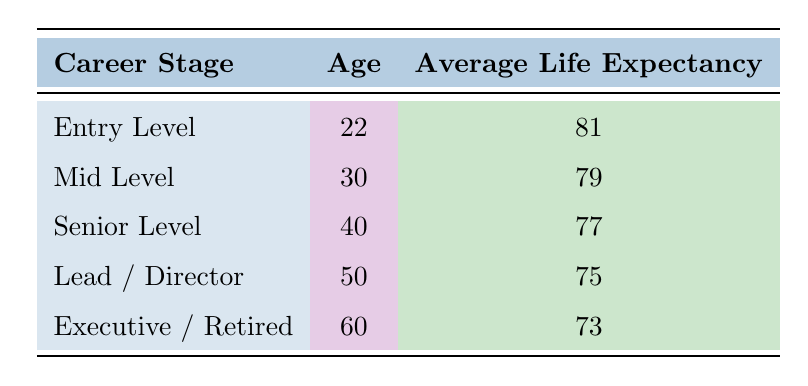What is the average life expectancy for a game developer at entry-level age? Referring to the table, the life expectancy for entry-level game developers is stated directly next to their career stage and age, which is 81.
Answer: 81 What is the age of game developers at the senior level? The table lists the career stage "Senior Level" and shows the corresponding age, which is 40.
Answer: 40 Is the average life expectancy for mid-level game developers higher than that for lead/director level? The average life expectancy for mid-level game developers is 79, and for lead/director level, it is 75. Since 79 is greater than 75, the statement is true.
Answer: Yes What is the difference in average life expectancy between entry-level and executive/retired game developers? The life expectancy for entry-level developers is 81, and for executive/retired is 73. The difference is calculated as 81 - 73 = 8.
Answer: 8 How many career stages are listed in the table? The table presents five distinct career stages: Entry Level, Mid Level, Senior Level, Lead / Director, and Executive / Retired, totaling five stages.
Answer: 5 What is the average life expectancy for game developers at 50 years old? The table shows that the average life expectancy for game developers at 50 years old, who are in the Lead / Director stage, is 75.
Answer: 75 Does the life expectancy decline consistently as the career stage progresses? By examining the life expectancy values in the table, we find that values decrease from 81 to 73 consecutively as the career stage progresses: 81, 79, 77, 75, 73. Thus, the life expectancy does decrease consistently.
Answer: Yes What is the average life expectancy for all game developers listed in the table? To find the average, we first sum all the life expectancy values: 81 + 79 + 77 + 75 + 73 = 385. Then, divide by 5 (the number of data points): 385 / 5 = 77.
Answer: 77 What is the career stage with the lowest average life expectancy? Looking through the life expectancy values, the lowest average is 73, which corresponds to the Executive / Retired career stage.
Answer: Executive / Retired 